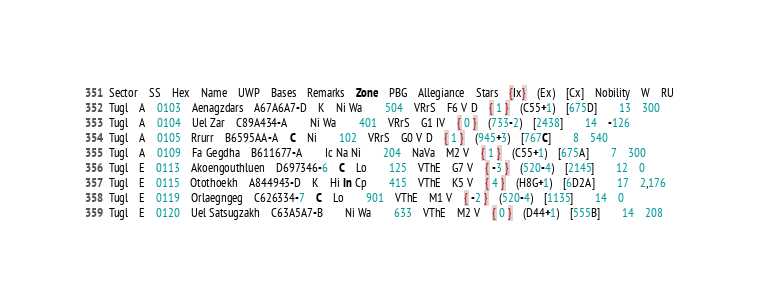Convert code to text. <code><loc_0><loc_0><loc_500><loc_500><_SQL_>Sector	SS	Hex	Name	UWP	Bases	Remarks	Zone	PBG	Allegiance	Stars	{Ix}	(Ex)	[Cx]	Nobility	W	RU
Tugl	A	0103	Aenagzdars	A67A6A7-D	K	Ni Wa		504	VRrS	F6 V D	{ 1 }	(C55+1)	[675D]		13	300
Tugl	A	0104	Uel Zar	C89A434-A		Ni Wa		401	VRrS	G1 IV	{ 0 }	(733-2)	[2438]		14	-126
Tugl	A	0105	Rrurr	B6595AA-A	C	Ni		102	VRrS	G0 V D	{ 1 }	(945+3)	[767C]		8	540
Tugl	A	0109	Fa Gegdha	B611677-A		Ic Na Ni		204	NaVa	M2 V	{ 1 }	(C55+1)	[675A]		7	300
Tugl	E	0113	Akoengouthluen	D697346-6	C	Lo		125	VThE	G7 V	{ -3 }	(520-4)	[2145]		12	0
Tugl	E	0115	Otothoekh	A844943-D	K	Hi In Cp		415	VThE	K5 V	{ 4 }	(H8G+1)	[6D2A]		17	2,176
Tugl	E	0119	Orlaegngeg	C626334-7	C	Lo		901	VThE	M1 V	{ -2 }	(520-4)	[1135]		14	0
Tugl	E	0120	Uel Satsugzakh	C63A5A7-B		Ni Wa		633	VThE	M2 V	{ 0 }	(D44+1)	[555B]		14	208</code> 